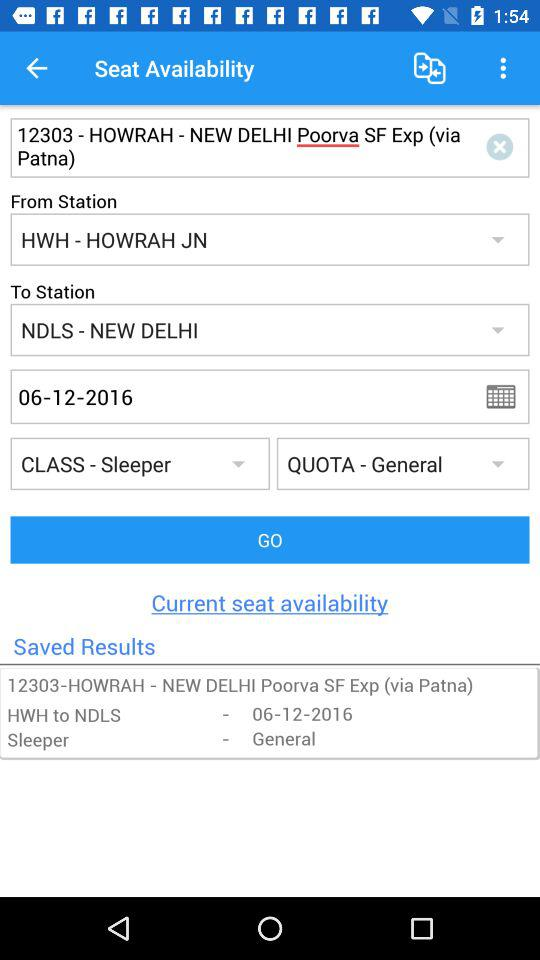Which holiday falls on July 12, 2016?
When the provided information is insufficient, respond with <no answer>. <no answer> 